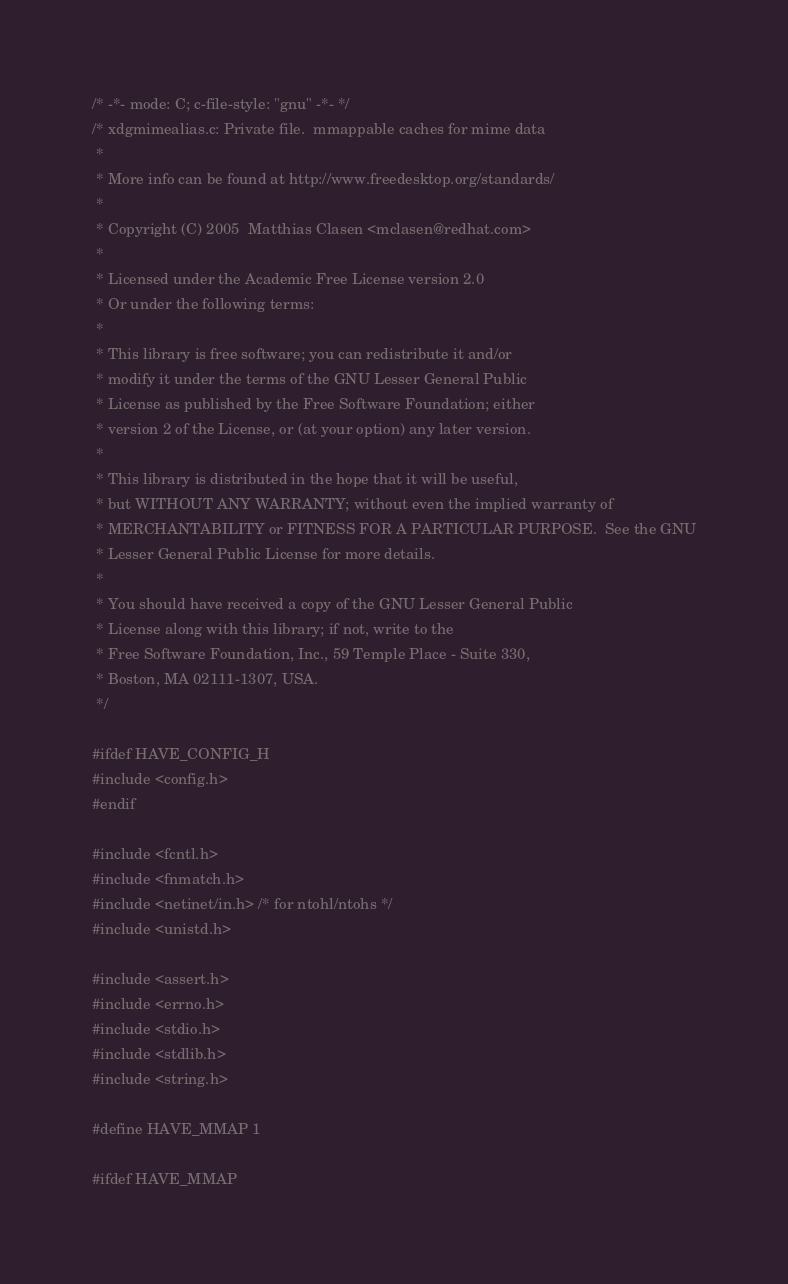<code> <loc_0><loc_0><loc_500><loc_500><_C_>/* -*- mode: C; c-file-style: "gnu" -*- */
/* xdgmimealias.c: Private file.  mmappable caches for mime data
 *
 * More info can be found at http://www.freedesktop.org/standards/
 *
 * Copyright (C) 2005  Matthias Clasen <mclasen@redhat.com>
 *
 * Licensed under the Academic Free License version 2.0
 * Or under the following terms:
 *
 * This library is free software; you can redistribute it and/or
 * modify it under the terms of the GNU Lesser General Public
 * License as published by the Free Software Foundation; either
 * version 2 of the License, or (at your option) any later version.
 *
 * This library is distributed in the hope that it will be useful,
 * but WITHOUT ANY WARRANTY; without even the implied warranty of
 * MERCHANTABILITY or FITNESS FOR A PARTICULAR PURPOSE.	 See the GNU
 * Lesser General Public License for more details.
 *
 * You should have received a copy of the GNU Lesser General Public
 * License along with this library; if not, write to the
 * Free Software Foundation, Inc., 59 Temple Place - Suite 330,
 * Boston, MA 02111-1307, USA.
 */

#ifdef HAVE_CONFIG_H
#include <config.h>
#endif

#include <fcntl.h>
#include <fnmatch.h>
#include <netinet/in.h> /* for ntohl/ntohs */
#include <unistd.h>

#include <assert.h>
#include <errno.h>
#include <stdio.h>
#include <stdlib.h>
#include <string.h>

#define HAVE_MMAP 1

#ifdef HAVE_MMAP</code> 